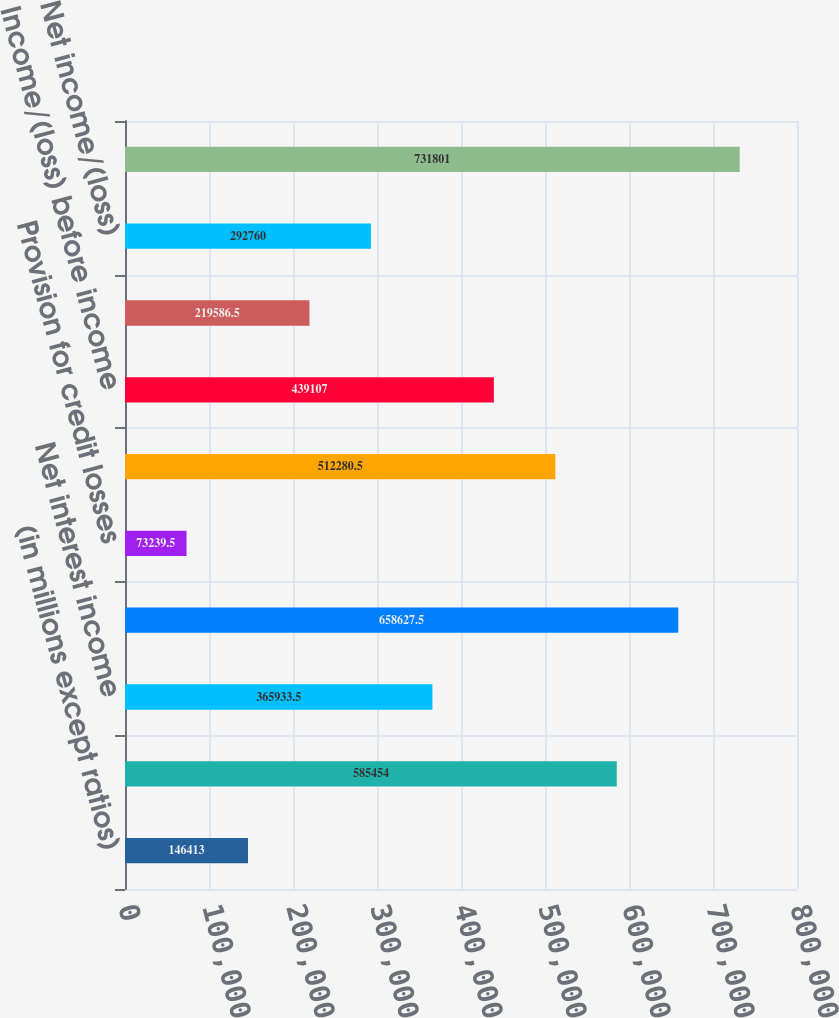<chart> <loc_0><loc_0><loc_500><loc_500><bar_chart><fcel>(in millions except ratios)<fcel>Noninterest revenue<fcel>Net interest income<fcel>Total net revenue<fcel>Provision for credit losses<fcel>Noninterest expense (c)<fcel>Income/(loss) before income<fcel>extraordinary gain<fcel>Net income/(loss)<fcel>Average common equity<nl><fcel>146413<fcel>585454<fcel>365934<fcel>658628<fcel>73239.5<fcel>512280<fcel>439107<fcel>219586<fcel>292760<fcel>731801<nl></chart> 